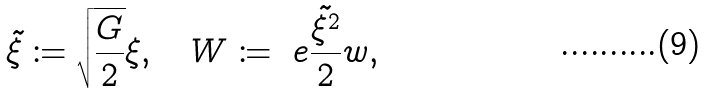Convert formula to latex. <formula><loc_0><loc_0><loc_500><loc_500>\tilde { \xi } \coloneqq \sqrt { \frac { G } { 2 } } \xi , \quad W \coloneqq \ e { \frac { \tilde { \xi ^ { 2 } } } { 2 } } w ,</formula> 